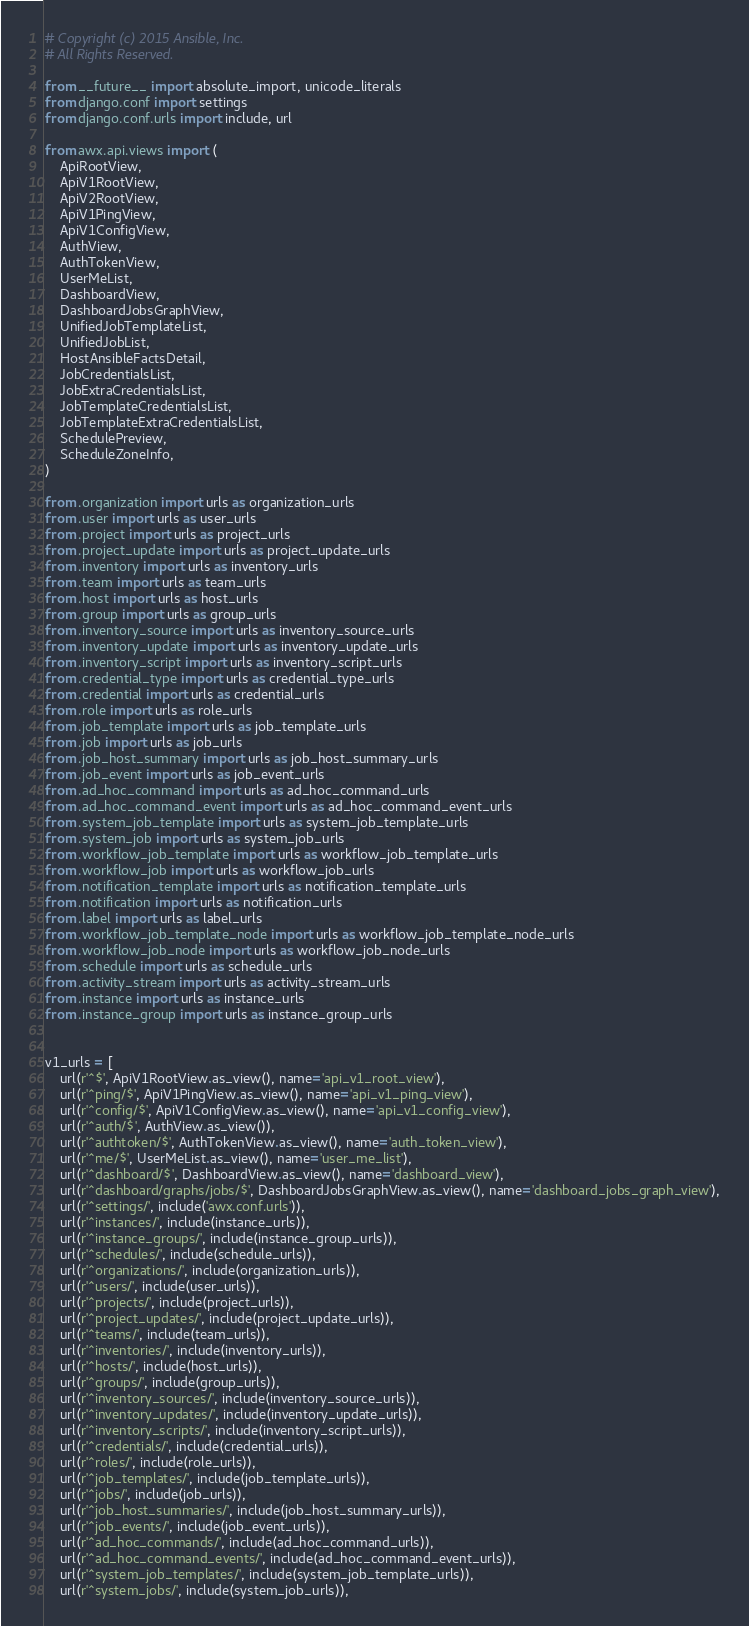<code> <loc_0><loc_0><loc_500><loc_500><_Python_># Copyright (c) 2015 Ansible, Inc.
# All Rights Reserved.

from __future__ import absolute_import, unicode_literals
from django.conf import settings
from django.conf.urls import include, url

from awx.api.views import (
    ApiRootView,
    ApiV1RootView,
    ApiV2RootView,
    ApiV1PingView,
    ApiV1ConfigView,
    AuthView,
    AuthTokenView,
    UserMeList,
    DashboardView,
    DashboardJobsGraphView,
    UnifiedJobTemplateList,
    UnifiedJobList,
    HostAnsibleFactsDetail,
    JobCredentialsList,
    JobExtraCredentialsList,
    JobTemplateCredentialsList,
    JobTemplateExtraCredentialsList,
    SchedulePreview,
    ScheduleZoneInfo,
)

from .organization import urls as organization_urls
from .user import urls as user_urls
from .project import urls as project_urls
from .project_update import urls as project_update_urls
from .inventory import urls as inventory_urls
from .team import urls as team_urls
from .host import urls as host_urls
from .group import urls as group_urls
from .inventory_source import urls as inventory_source_urls
from .inventory_update import urls as inventory_update_urls
from .inventory_script import urls as inventory_script_urls
from .credential_type import urls as credential_type_urls
from .credential import urls as credential_urls
from .role import urls as role_urls
from .job_template import urls as job_template_urls
from .job import urls as job_urls
from .job_host_summary import urls as job_host_summary_urls
from .job_event import urls as job_event_urls
from .ad_hoc_command import urls as ad_hoc_command_urls
from .ad_hoc_command_event import urls as ad_hoc_command_event_urls
from .system_job_template import urls as system_job_template_urls
from .system_job import urls as system_job_urls
from .workflow_job_template import urls as workflow_job_template_urls
from .workflow_job import urls as workflow_job_urls
from .notification_template import urls as notification_template_urls
from .notification import urls as notification_urls
from .label import urls as label_urls
from .workflow_job_template_node import urls as workflow_job_template_node_urls
from .workflow_job_node import urls as workflow_job_node_urls
from .schedule import urls as schedule_urls
from .activity_stream import urls as activity_stream_urls
from .instance import urls as instance_urls
from .instance_group import urls as instance_group_urls


v1_urls = [
    url(r'^$', ApiV1RootView.as_view(), name='api_v1_root_view'),
    url(r'^ping/$', ApiV1PingView.as_view(), name='api_v1_ping_view'),
    url(r'^config/$', ApiV1ConfigView.as_view(), name='api_v1_config_view'),
    url(r'^auth/$', AuthView.as_view()),
    url(r'^authtoken/$', AuthTokenView.as_view(), name='auth_token_view'),
    url(r'^me/$', UserMeList.as_view(), name='user_me_list'),
    url(r'^dashboard/$', DashboardView.as_view(), name='dashboard_view'),
    url(r'^dashboard/graphs/jobs/$', DashboardJobsGraphView.as_view(), name='dashboard_jobs_graph_view'),
    url(r'^settings/', include('awx.conf.urls')),
    url(r'^instances/', include(instance_urls)),
    url(r'^instance_groups/', include(instance_group_urls)),
    url(r'^schedules/', include(schedule_urls)),
    url(r'^organizations/', include(organization_urls)),
    url(r'^users/', include(user_urls)),
    url(r'^projects/', include(project_urls)),
    url(r'^project_updates/', include(project_update_urls)),
    url(r'^teams/', include(team_urls)),
    url(r'^inventories/', include(inventory_urls)),
    url(r'^hosts/', include(host_urls)),
    url(r'^groups/', include(group_urls)),
    url(r'^inventory_sources/', include(inventory_source_urls)),
    url(r'^inventory_updates/', include(inventory_update_urls)),
    url(r'^inventory_scripts/', include(inventory_script_urls)),
    url(r'^credentials/', include(credential_urls)),
    url(r'^roles/', include(role_urls)),
    url(r'^job_templates/', include(job_template_urls)),
    url(r'^jobs/', include(job_urls)),
    url(r'^job_host_summaries/', include(job_host_summary_urls)),
    url(r'^job_events/', include(job_event_urls)),
    url(r'^ad_hoc_commands/', include(ad_hoc_command_urls)),
    url(r'^ad_hoc_command_events/', include(ad_hoc_command_event_urls)),
    url(r'^system_job_templates/', include(system_job_template_urls)),
    url(r'^system_jobs/', include(system_job_urls)),</code> 